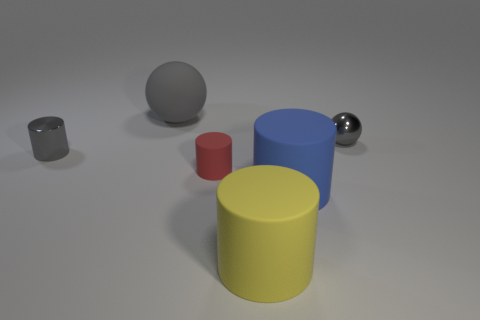There is a rubber cylinder that is both on the right side of the small red matte cylinder and behind the big yellow rubber object; what size is it?
Provide a succinct answer. Large. Does the tiny matte object have the same color as the rubber cylinder in front of the big blue cylinder?
Provide a short and direct response. No. What number of blue objects are big cylinders or shiny balls?
Keep it short and to the point. 1. There is a red object; what shape is it?
Your response must be concise. Cylinder. How many other things are there of the same shape as the tiny red matte object?
Make the answer very short. 3. The large object behind the blue rubber cylinder is what color?
Offer a terse response. Gray. Is the material of the red cylinder the same as the large blue cylinder?
Provide a short and direct response. Yes. How many things are either yellow rubber cylinders or tiny things that are on the right side of the small red matte thing?
Give a very brief answer. 2. The rubber thing that is the same color as the small shiny ball is what size?
Offer a very short reply. Large. What shape is the object that is left of the gray matte object?
Your answer should be very brief. Cylinder. 